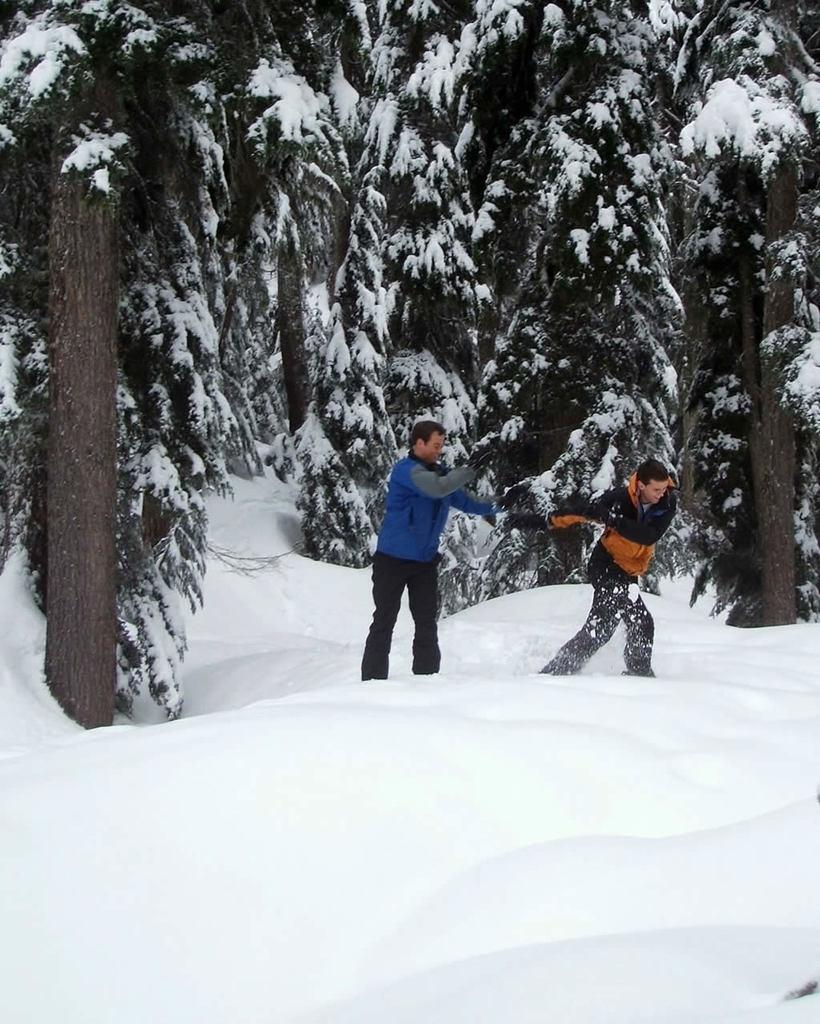What is the main feature of the landscape in the image? There are many trees in the image. What is the weather like in the image? There is snow visible in the image, indicating a cold and likely wintery scene. How many people are in the image? There are two persons in the image. What type of songs are the trees singing in the image? Trees do not sing songs, so this question cannot be answered based on the information provided in the image. 